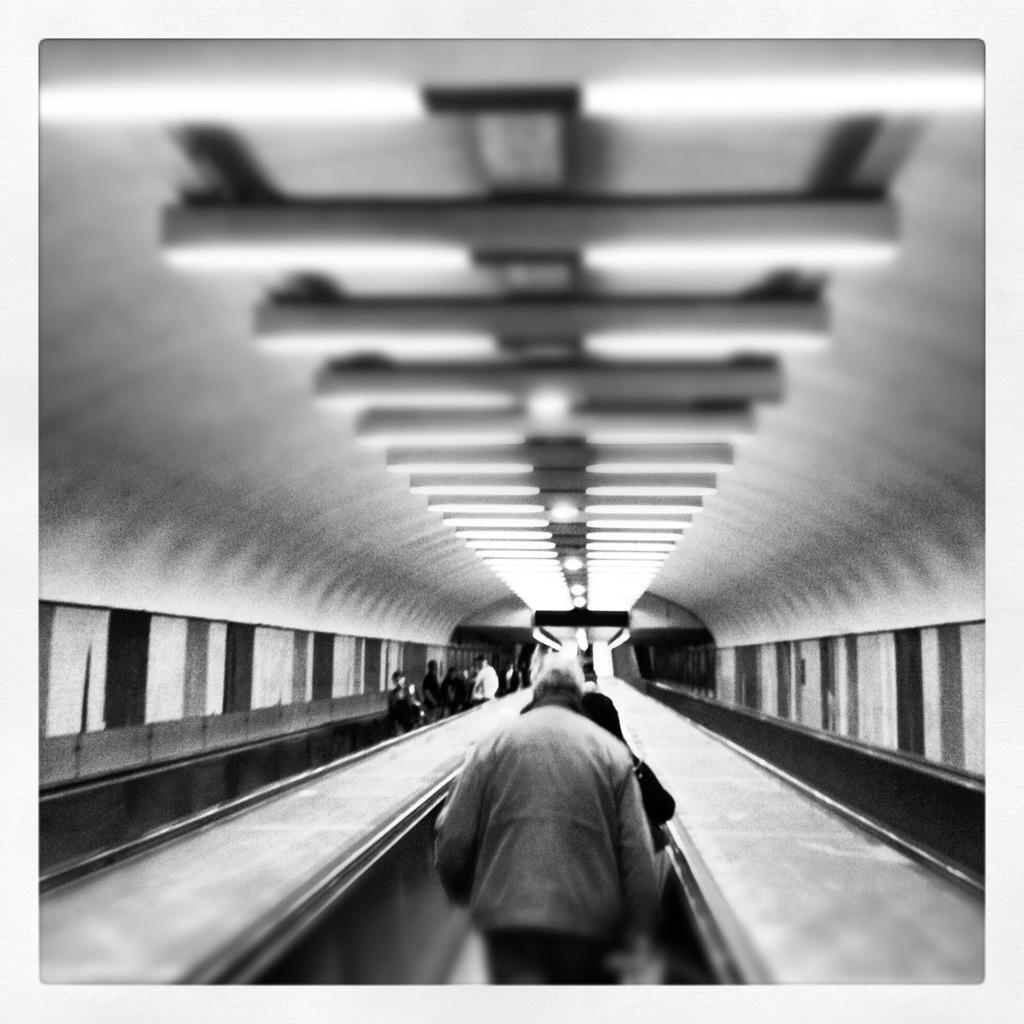How would you summarize this image in a sentence or two? In this black and white picture there are people and light on the roof. 